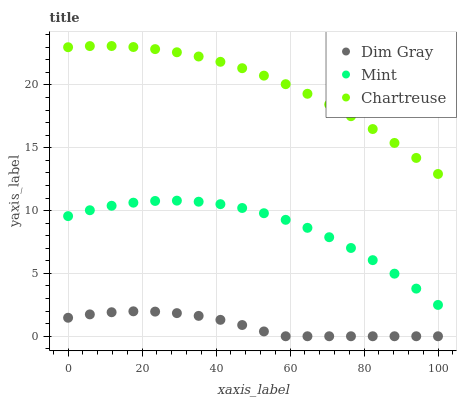Does Dim Gray have the minimum area under the curve?
Answer yes or no. Yes. Does Chartreuse have the maximum area under the curve?
Answer yes or no. Yes. Does Mint have the minimum area under the curve?
Answer yes or no. No. Does Mint have the maximum area under the curve?
Answer yes or no. No. Is Dim Gray the smoothest?
Answer yes or no. Yes. Is Mint the roughest?
Answer yes or no. Yes. Is Mint the smoothest?
Answer yes or no. No. Is Dim Gray the roughest?
Answer yes or no. No. Does Dim Gray have the lowest value?
Answer yes or no. Yes. Does Mint have the lowest value?
Answer yes or no. No. Does Chartreuse have the highest value?
Answer yes or no. Yes. Does Mint have the highest value?
Answer yes or no. No. Is Mint less than Chartreuse?
Answer yes or no. Yes. Is Mint greater than Dim Gray?
Answer yes or no. Yes. Does Mint intersect Chartreuse?
Answer yes or no. No. 